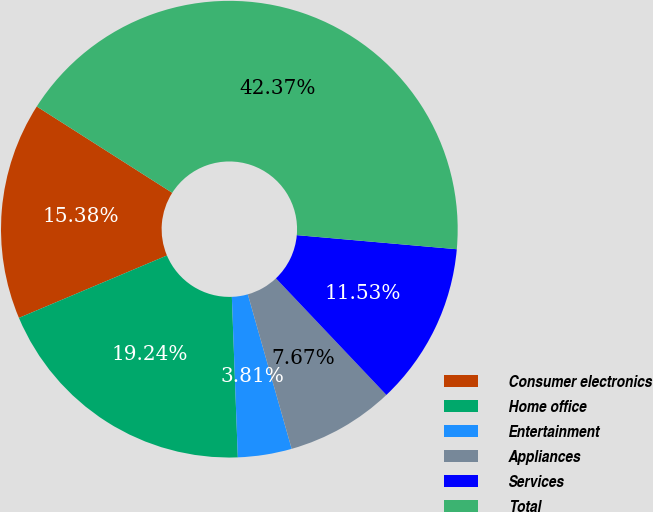Convert chart to OTSL. <chart><loc_0><loc_0><loc_500><loc_500><pie_chart><fcel>Consumer electronics<fcel>Home office<fcel>Entertainment<fcel>Appliances<fcel>Services<fcel>Total<nl><fcel>15.38%<fcel>19.24%<fcel>3.81%<fcel>7.67%<fcel>11.53%<fcel>42.37%<nl></chart> 